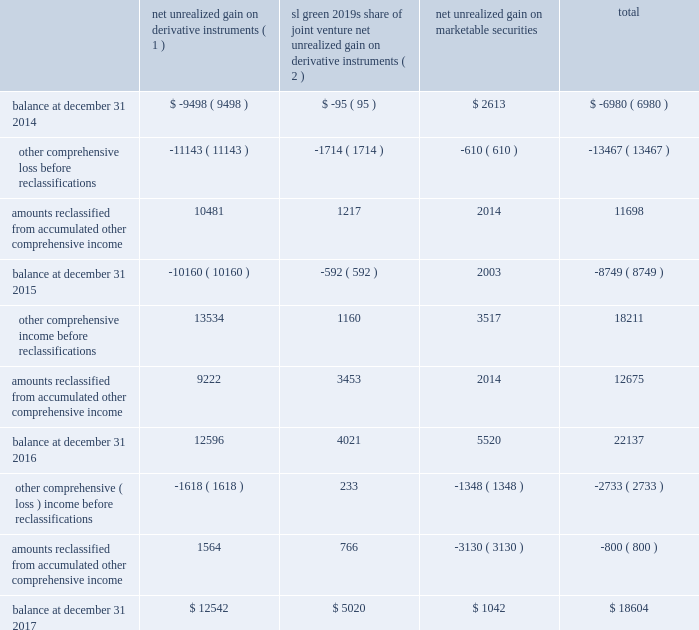108 / sl green realty corp .
2017 annual report espp provides for eligible employees to purchase the common stock at a purchase price equal to 85% ( 85 % ) of the lesser of ( 1 ) a0the market value of the common stock on the first day of the offer- ing period or ( 2 ) a0the market value of the common stock on the last day of the offering period .
The espp was approved by our stockholders at our 2008 annual meeting of stockholders .
As of december a031 , 2017 , 104597 a0shares of our common stock had been issued under the espp .
Available for issuance , subject to adjustment upon a merger , reorganization , stock split or other similar corporate change .
The company filed a registration statement on form a0s-8 with the sec with respect to the espp .
The common stock is offered for purchase through a series of successive offering periods .
Each offering period will be three months in duration and will begin on the first day of each calendar quarter , with the first a0offering period having commenced on january a01 , 2008 .
The 15 .
Accumulated other comprehensive income the tables set forth the changes in accumulated other comprehensive income ( loss ) by component as of december a031 , 2017 , 2016 and 2015 ( in thousands ) : sl a0green 2019s share net unrealized of joint venture net unrealized gain on net unrealized gain on derivative gain on derivative marketable instruments ( 1 ) instruments ( 2 ) securities total .
( 1 ) amount reclassified from accumulated other comprehensive income ( loss ) is included in interest expense in the respective consolidated statements of operations .
As of december a031 , 2017 and 2016 , the deferred net losses from these terminated hedges , which is included in accumulated other comprehensive loss relating to net unrealized loss on derivative instrument , was $ 3.2 a0million and $ 7.1 a0million , respectively .
( 2 ) amount reclassified from accumulated other comprehensive income ( loss ) is included in equity in net income from unconsolidated joint ventures in the respective consolidated statements of operations .
16 .
Fair value measurements we are required to disclose fair value information with regard to our financial instruments , whether or not recognized in the consolidated balance sheets , for which it is practical to estimate fair value .
The fasb guidance defines fair value as the price that would be received to sell an asset or paid to transfer a liability in an orderly transaction between market participants on the measurement date .
We measure and/or disclose the estimated fair value of financial assets and liabilities based on a hierarchy that distinguishes between market participant assumptions based on market data obtained from sources independent of the reporting entity and the reporting entity 2019s own assumptions about market participant assumptions .
This hierarchy consists of three broad levels : level a01 2014 quoted prices ( unadjusted ) in active markets for identical assets or liabilities that the reporting entity can access at the measurement date ; level a02 2014 inputs other than quoted prices included within level a01 , that are observable for the asset or liability , either directly or indirectly ; and level a03 2014 unobservable inputs for the asset or liability that are used when little or no market data is available .
We follow this hierarchy for our assets and liabilities measured at fair value on a recurring and nonrecurring basis .
In instances in which the determination of the fair value measurement is based on inputs from different levels of the fair value hierarchy , the level in the fair value hierarchy within which the entire fair value measure- ment falls is based on the lowest level of input that is significant to the fair value measurement in its entirety .
Our assessment of the significance of the particular input to the fair value mea- surement in its entirety requires judgment and considers factors specific to the asset or liability. .
What was the net three year change in the aoci balance for all derivatives and marketable securities? 
Computations: (-6980 - 18604)
Answer: -25584.0. 